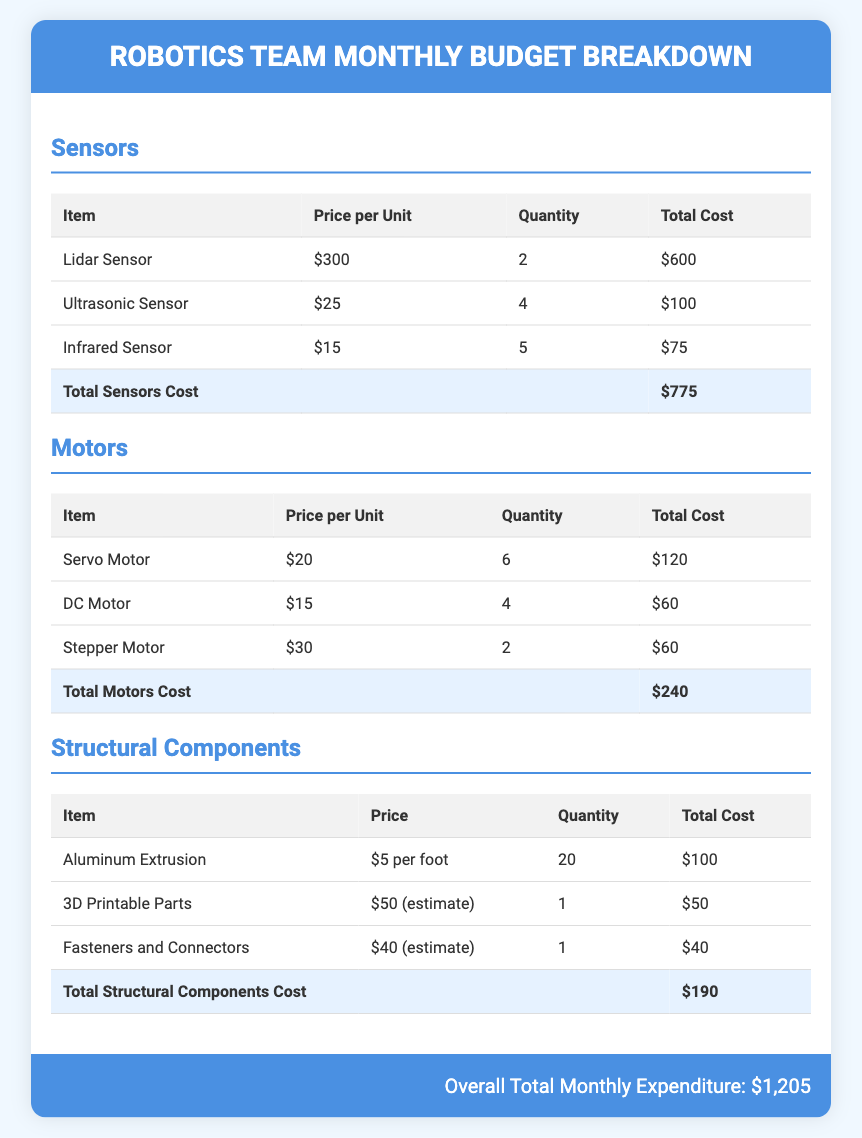What is the total cost of sensors? The total cost of sensors is listed at the bottom of the sensors section of the document.
Answer: $775 How many Lidar Sensors are included? The quantity of Lidar Sensors is mentioned in the sensors table.
Answer: 2 What is the price per unit of a Servo Motor? The price per unit of a Servo Motor is shown in the motors table.
Answer: $20 What is the total expenditure for motors? The total cost of motors can be found in the summary of the motors section.
Answer: $240 How many feet of Aluminum Extrusion are needed? The quantity of Aluminum Extrusion is specified in the structural components table.
Answer: 20 What is the total monthly expenditure for the robotics team? The overall total monthly expenditure is provided at the bottom of the document.
Answer: $1,205 What is the estimated cost of 3D Printable Parts? The estimated cost of 3D Printable Parts is stated in the structural components table.
Answer: $50 Which item has the highest cost under sensors? The item with the highest cost is determined by comparing the total costs in the sensors table.
Answer: Lidar Sensor 